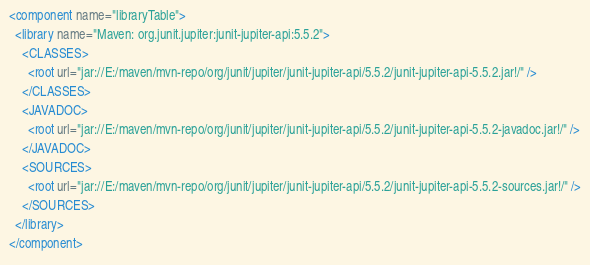<code> <loc_0><loc_0><loc_500><loc_500><_XML_><component name="libraryTable">
  <library name="Maven: org.junit.jupiter:junit-jupiter-api:5.5.2">
    <CLASSES>
      <root url="jar://E:/maven/mvn-repo/org/junit/jupiter/junit-jupiter-api/5.5.2/junit-jupiter-api-5.5.2.jar!/" />
    </CLASSES>
    <JAVADOC>
      <root url="jar://E:/maven/mvn-repo/org/junit/jupiter/junit-jupiter-api/5.5.2/junit-jupiter-api-5.5.2-javadoc.jar!/" />
    </JAVADOC>
    <SOURCES>
      <root url="jar://E:/maven/mvn-repo/org/junit/jupiter/junit-jupiter-api/5.5.2/junit-jupiter-api-5.5.2-sources.jar!/" />
    </SOURCES>
  </library>
</component></code> 